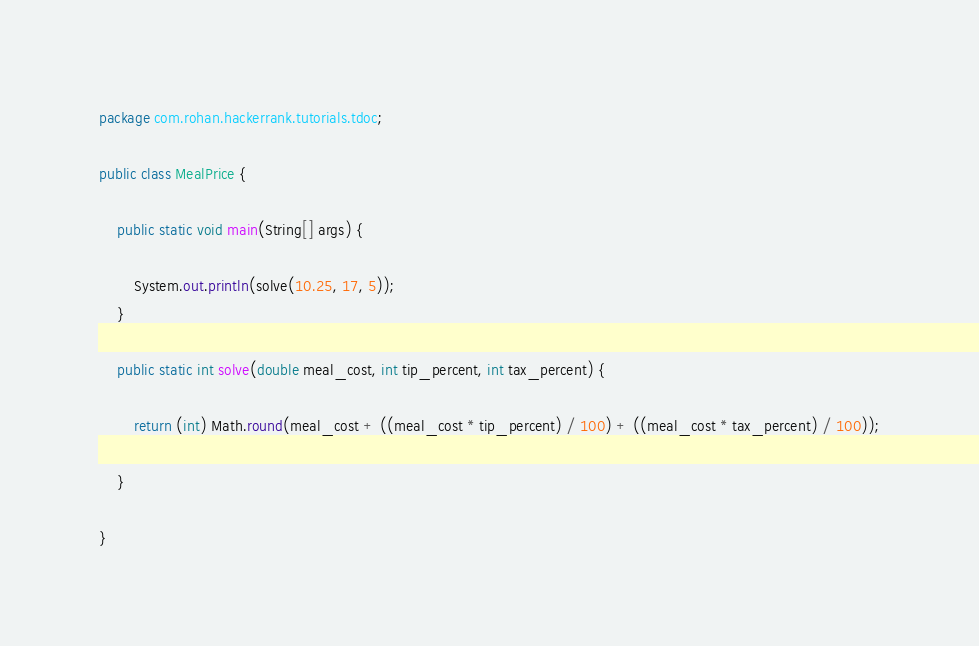<code> <loc_0><loc_0><loc_500><loc_500><_Java_>package com.rohan.hackerrank.tutorials.tdoc;

public class MealPrice {

	public static void main(String[] args) {

		System.out.println(solve(10.25, 17, 5));
	}

	public static int solve(double meal_cost, int tip_percent, int tax_percent) {

		return (int) Math.round(meal_cost + ((meal_cost * tip_percent) / 100) + ((meal_cost * tax_percent) / 100));

	}

}
</code> 